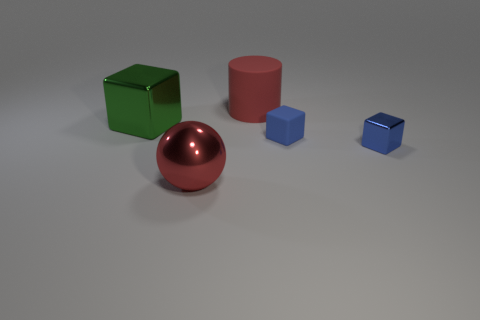How many objects are depicted, and can you describe their shapes and colors? There are five objects displayed. From left to right: a green cube, a large red cylinder, a shiny red sphere, a medium-sized blue cube, and a small dark blue cube. 